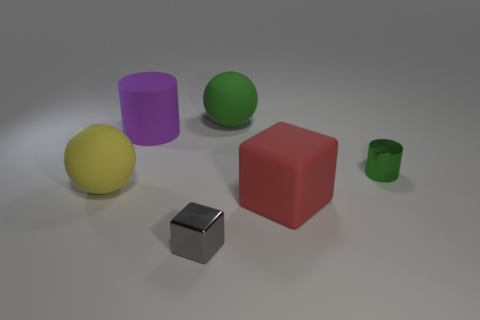Is the material of the small block the same as the big sphere that is to the right of the large purple matte object?
Provide a succinct answer. No. What is the material of the cylinder that is the same size as the yellow rubber sphere?
Give a very brief answer. Rubber. Are there any matte cubes of the same size as the yellow sphere?
Make the answer very short. Yes. The red rubber object that is the same size as the purple rubber cylinder is what shape?
Ensure brevity in your answer.  Cube. What number of other objects are there of the same color as the metal cube?
Provide a short and direct response. 0. What is the shape of the object that is in front of the rubber cylinder and on the left side of the tiny gray thing?
Offer a very short reply. Sphere. Are there any tiny gray objects right of the block to the left of the large sphere that is to the right of the yellow thing?
Make the answer very short. No. What number of other objects are there of the same material as the small cylinder?
Provide a succinct answer. 1. How many rubber blocks are there?
Provide a short and direct response. 1. What number of objects are yellow spheres or metallic things behind the gray block?
Provide a short and direct response. 2. 